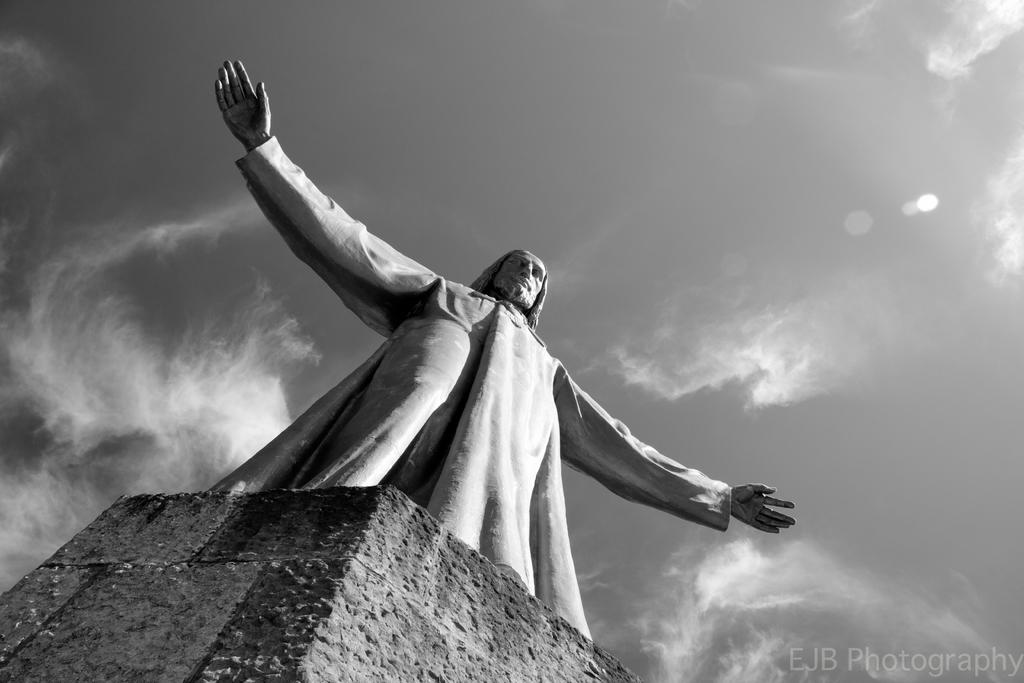What is the main subject in the middle of the image? There is a statue in the middle of the image. What can be seen in the background of the image? There is a wall in the background of the image. How would you describe the appearance of the wall? The wall appears to be cloudy. Where can the spark be seen in the image? There is no spark present in the image. What type of rest can be seen in the image? There is no rest or resting activity depicted in the image. 